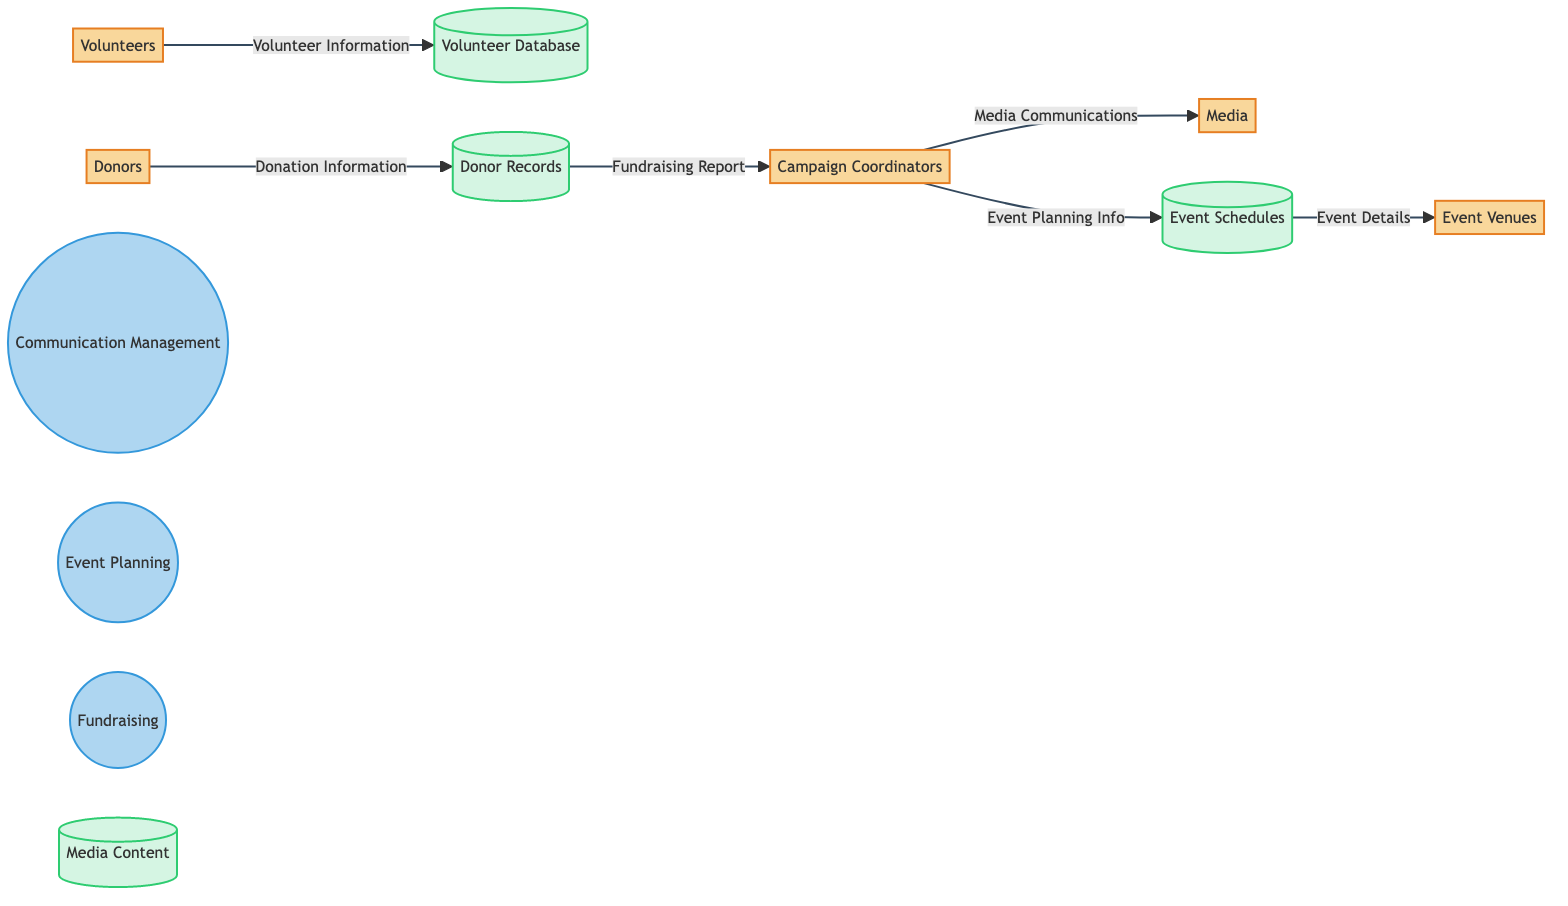What are the main entities involved in the grassroots activism campaign? The diagram lists five main entities: Volunteers, Campaign Coordinators, Donors, Event Venues, and Media. This can be determined by directly observing the entities defined in the diagram.
Answer: Volunteers, Campaign Coordinators, Donors, Event Venues, Media How many processes are represented in the diagram? The diagram shows three processes: Communication Management, Event Planning, and Fundraising. By counting the labeled processes in the diagram, we can arrive at this number.
Answer: 3 Which entity provides financial support? Donors are identified as the entity responsible for providing financial support. This information is included in the description of the Donors entity in the diagram.
Answer: Donors What type of information flow comes from Campaign Coordinators to Media? The flow of communication materials from Campaign Coordinators to Media is described as "Media Communications". This can be found in the data flow lines connecting these two entities in the diagram.
Answer: Media Communications Which storage contains volunteer information? The storage that holds volunteer information is the "Volunteer Database". This can be identified by the flow from Volunteers to this datastore in the diagram.
Answer: Volunteer Database What type of information flows from Donors to Campaign Coordinators? The flow of information from Donors to Campaign Coordinators is referred to as "Fundraising Report". By examining the flow lines in the diagram, this specific information flow can be identified.
Answer: Fundraising Report How many data stores are depicted in the diagram? The diagram shows four data stores: Volunteer Database, Donor Records, Event Schedules, and Media Content. Counting these stores in the diagram provides the answer.
Answer: 4 What action do Campaign Coordinators take related to Event Schedules? Campaign Coordinators transfer event planning details to Event Schedules, as indicated by the flow labeled "Event Planning Info" in the diagram. This explains their involvement with the Event Schedules data store.
Answer: Transfer event planning details Which process involves organizing events? The process responsible for organizing events is "Event Planning". This can be identified directly by the label of the process in the diagram.
Answer: Event Planning 